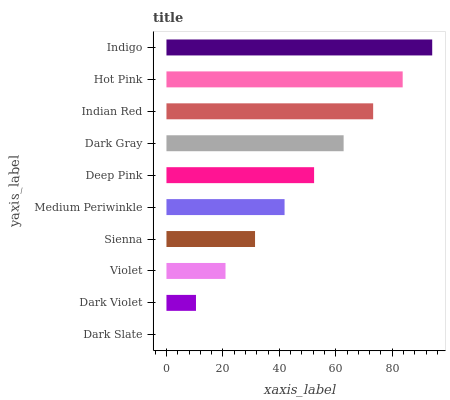Is Dark Slate the minimum?
Answer yes or no. Yes. Is Indigo the maximum?
Answer yes or no. Yes. Is Dark Violet the minimum?
Answer yes or no. No. Is Dark Violet the maximum?
Answer yes or no. No. Is Dark Violet greater than Dark Slate?
Answer yes or no. Yes. Is Dark Slate less than Dark Violet?
Answer yes or no. Yes. Is Dark Slate greater than Dark Violet?
Answer yes or no. No. Is Dark Violet less than Dark Slate?
Answer yes or no. No. Is Deep Pink the high median?
Answer yes or no. Yes. Is Medium Periwinkle the low median?
Answer yes or no. Yes. Is Hot Pink the high median?
Answer yes or no. No. Is Indian Red the low median?
Answer yes or no. No. 